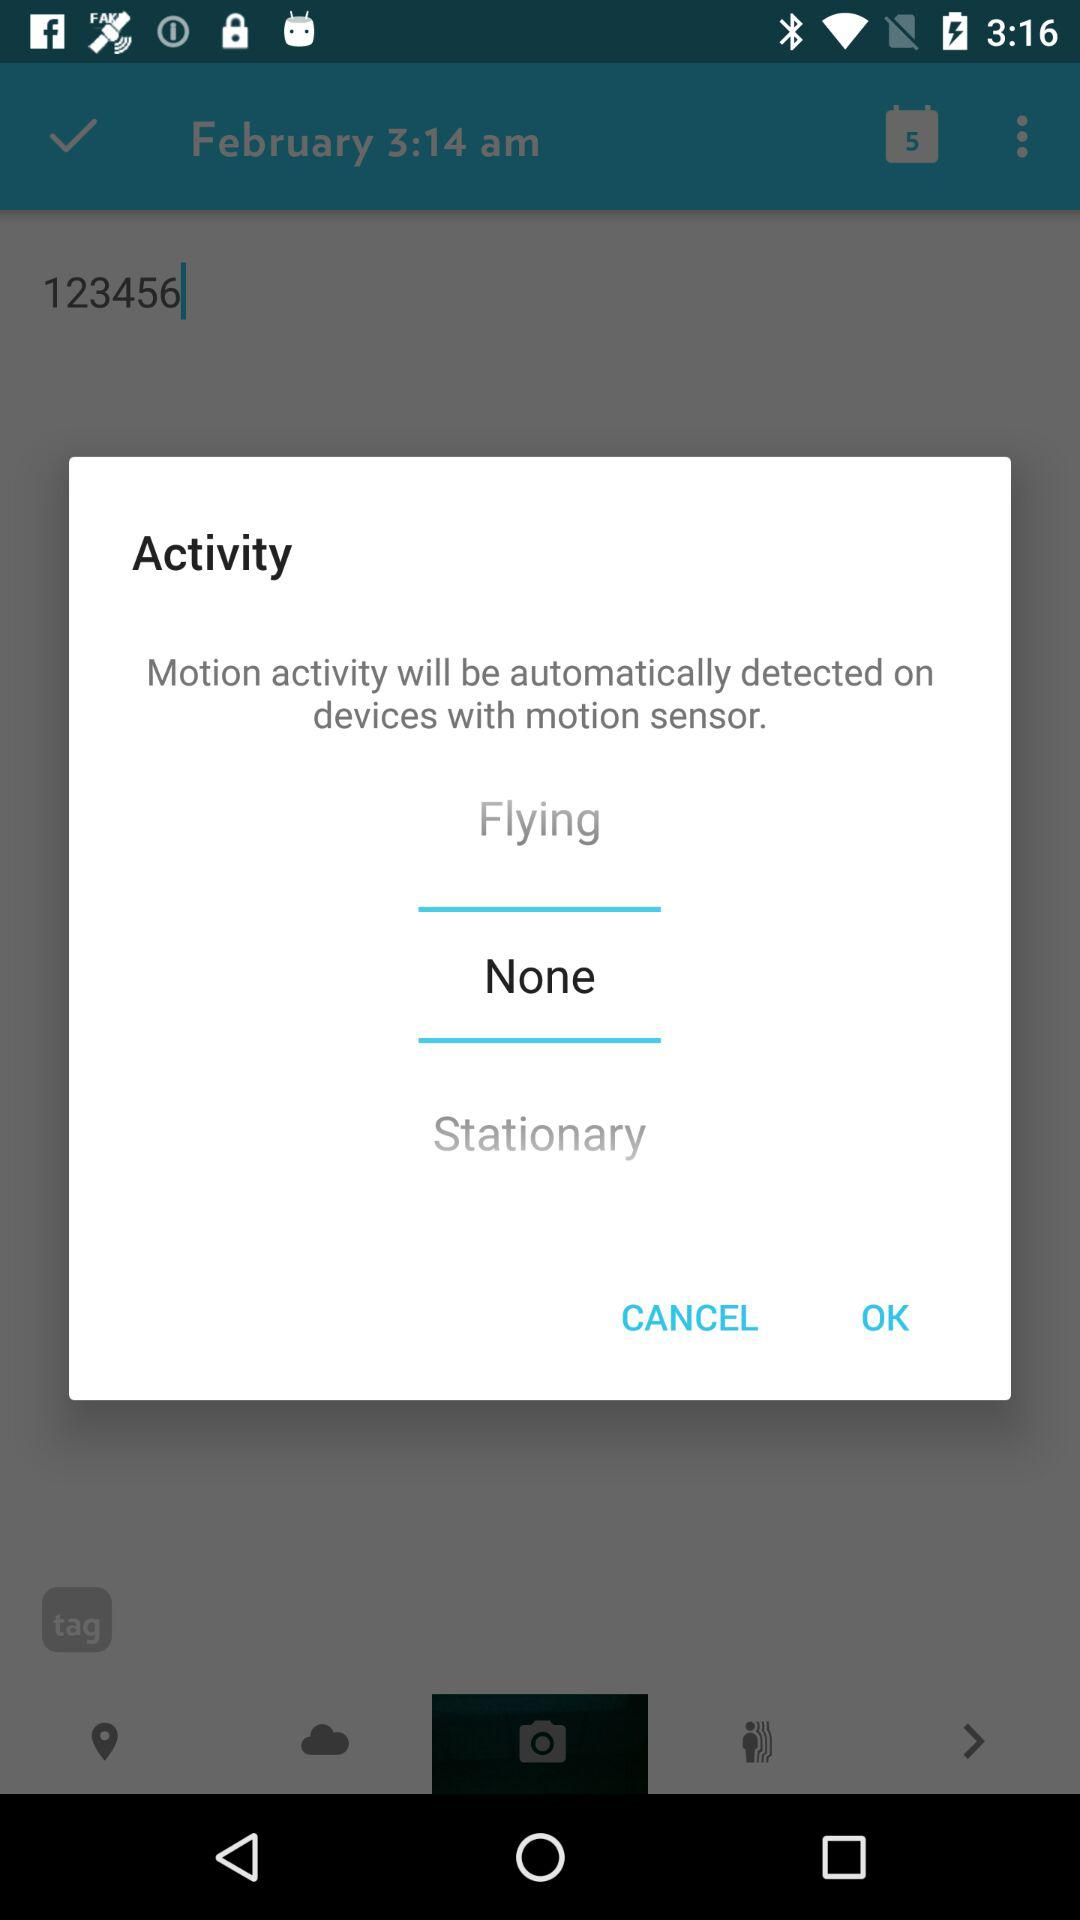How many photos were taken?
When the provided information is insufficient, respond with <no answer>. <no answer> 